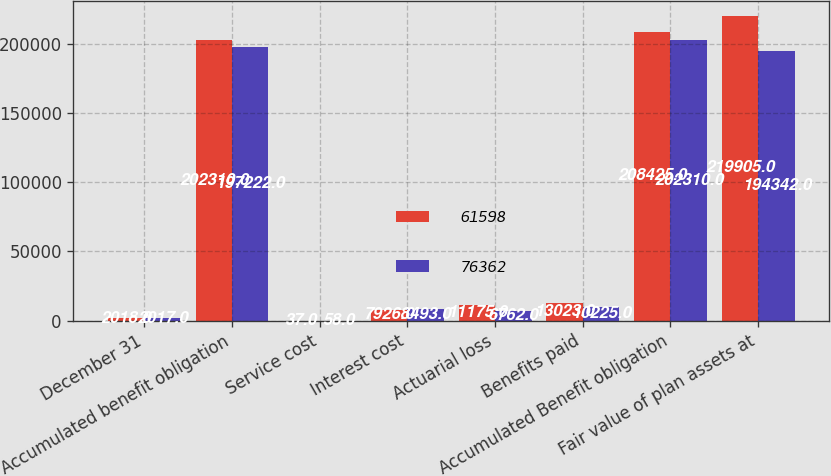Convert chart to OTSL. <chart><loc_0><loc_0><loc_500><loc_500><stacked_bar_chart><ecel><fcel>December 31<fcel>Accumulated benefit obligation<fcel>Service cost<fcel>Interest cost<fcel>Actuarial loss<fcel>Benefits paid<fcel>Accumulated Benefit obligation<fcel>Fair value of plan assets at<nl><fcel>61598<fcel>2018<fcel>202310<fcel>37<fcel>7926<fcel>11175<fcel>13023<fcel>208425<fcel>219905<nl><fcel>76362<fcel>2017<fcel>197222<fcel>58<fcel>8493<fcel>6762<fcel>10225<fcel>202310<fcel>194342<nl></chart> 